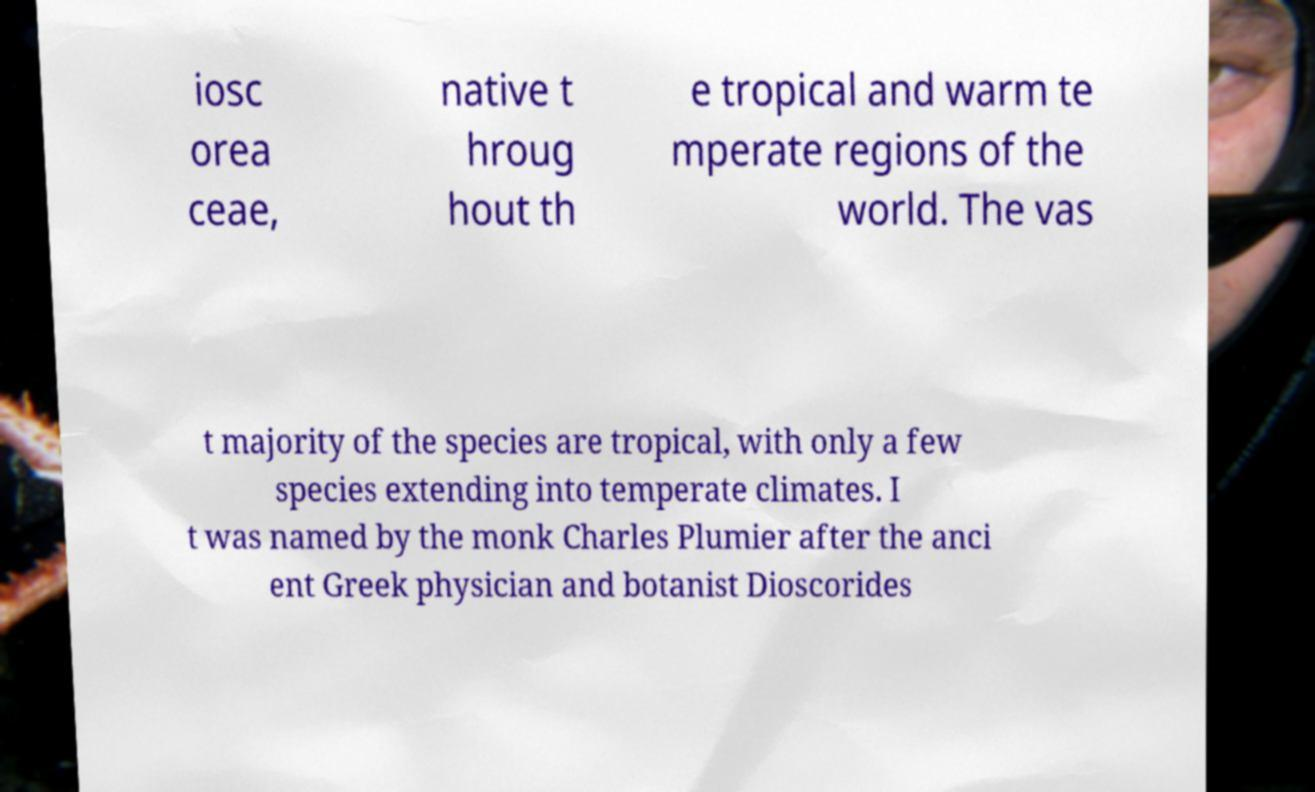There's text embedded in this image that I need extracted. Can you transcribe it verbatim? iosc orea ceae, native t hroug hout th e tropical and warm te mperate regions of the world. The vas t majority of the species are tropical, with only a few species extending into temperate climates. I t was named by the monk Charles Plumier after the anci ent Greek physician and botanist Dioscorides 